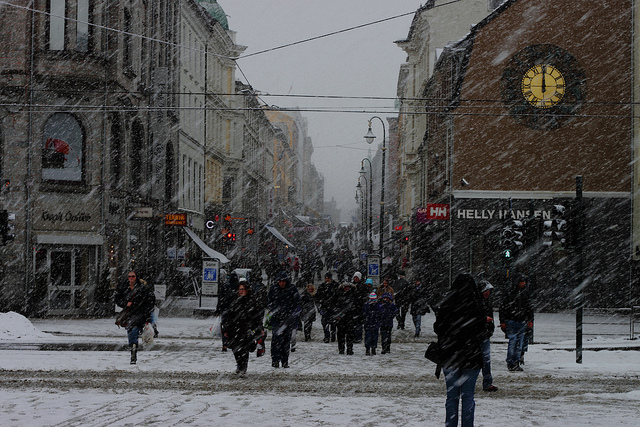Please identify all text content in this image. C HELLY HANSEN XI X VIII VII VI V IIII III II I XII 